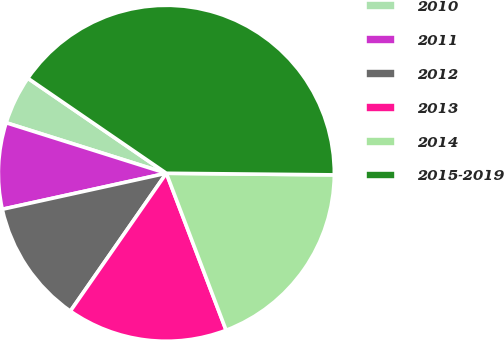Convert chart to OTSL. <chart><loc_0><loc_0><loc_500><loc_500><pie_chart><fcel>2010<fcel>2011<fcel>2012<fcel>2013<fcel>2014<fcel>2015-2019<nl><fcel>4.71%<fcel>8.3%<fcel>11.88%<fcel>15.47%<fcel>19.06%<fcel>40.58%<nl></chart> 